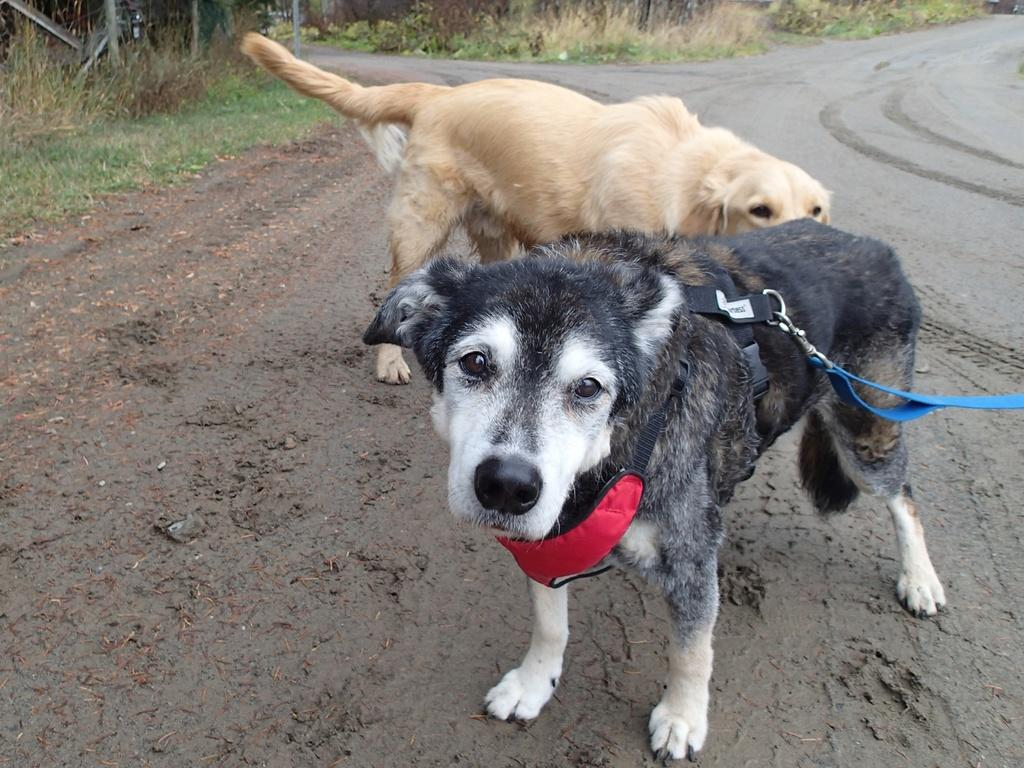What type of animals are in the image? There are dogs in the image. What colors can be seen on the dogs? The dogs are in brown, black, and white colors. Is there anything unique about one of the dogs? Yes, one of the dogs is wearing a belt. What can be seen in the background of the image? There is grass and trees in the background of the image. What type of brush can be seen in the image? There is no brush present in the image. How many eyes does the dog with the belt have? The image does not show the number of eyes the dog with the belt has, but since it is a dog, it typically has two eyes. 